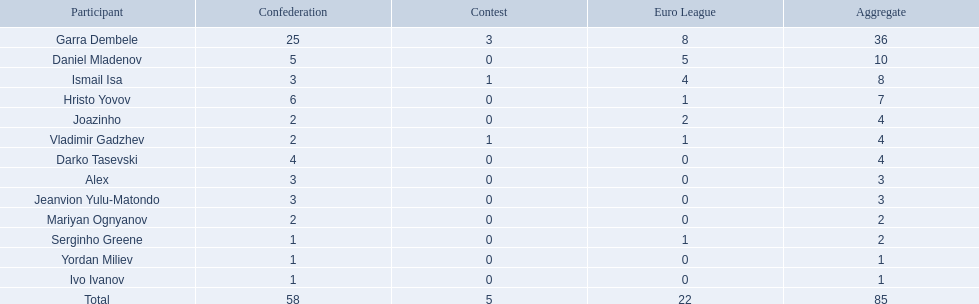Who are all of the players? Garra Dembele, Daniel Mladenov, Ismail Isa, Hristo Yovov, Joazinho, Vladimir Gadzhev, Darko Tasevski, Alex, Jeanvion Yulu-Matondo, Mariyan Ognyanov, Serginho Greene, Yordan Miliev, Ivo Ivanov. And which league is each player in? 25, 5, 3, 6, 2, 2, 4, 3, 3, 2, 1, 1, 1. Along with vladimir gadzhev and joazinho, which other player is in league 2? Mariyan Ognyanov. Would you be able to parse every entry in this table? {'header': ['Participant', 'Confederation', 'Contest', 'Euro League', 'Aggregate'], 'rows': [['Garra Dembele', '25', '3', '8', '36'], ['Daniel Mladenov', '5', '0', '5', '10'], ['Ismail Isa', '3', '1', '4', '8'], ['Hristo Yovov', '6', '0', '1', '7'], ['Joazinho', '2', '0', '2', '4'], ['Vladimir Gadzhev', '2', '1', '1', '4'], ['Darko Tasevski', '4', '0', '0', '4'], ['Alex', '3', '0', '0', '3'], ['Jeanvion Yulu-Matondo', '3', '0', '0', '3'], ['Mariyan Ognyanov', '2', '0', '0', '2'], ['Serginho Greene', '1', '0', '1', '2'], ['Yordan Miliev', '1', '0', '0', '1'], ['Ivo Ivanov', '1', '0', '0', '1'], ['Total', '58', '5', '22', '85']]} 